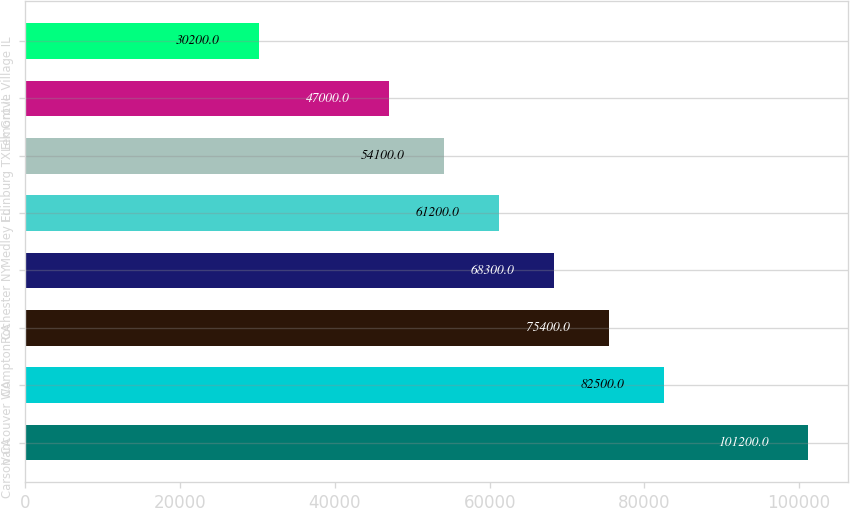Convert chart. <chart><loc_0><loc_0><loc_500><loc_500><bar_chart><fcel>Carson CA<fcel>Vancouver WA<fcel>Compton CA<fcel>Rochester NY<fcel>Medley FL<fcel>Edinburg TX<fcel>Lemont IL<fcel>Elk Grove Village IL<nl><fcel>101200<fcel>82500<fcel>75400<fcel>68300<fcel>61200<fcel>54100<fcel>47000<fcel>30200<nl></chart> 